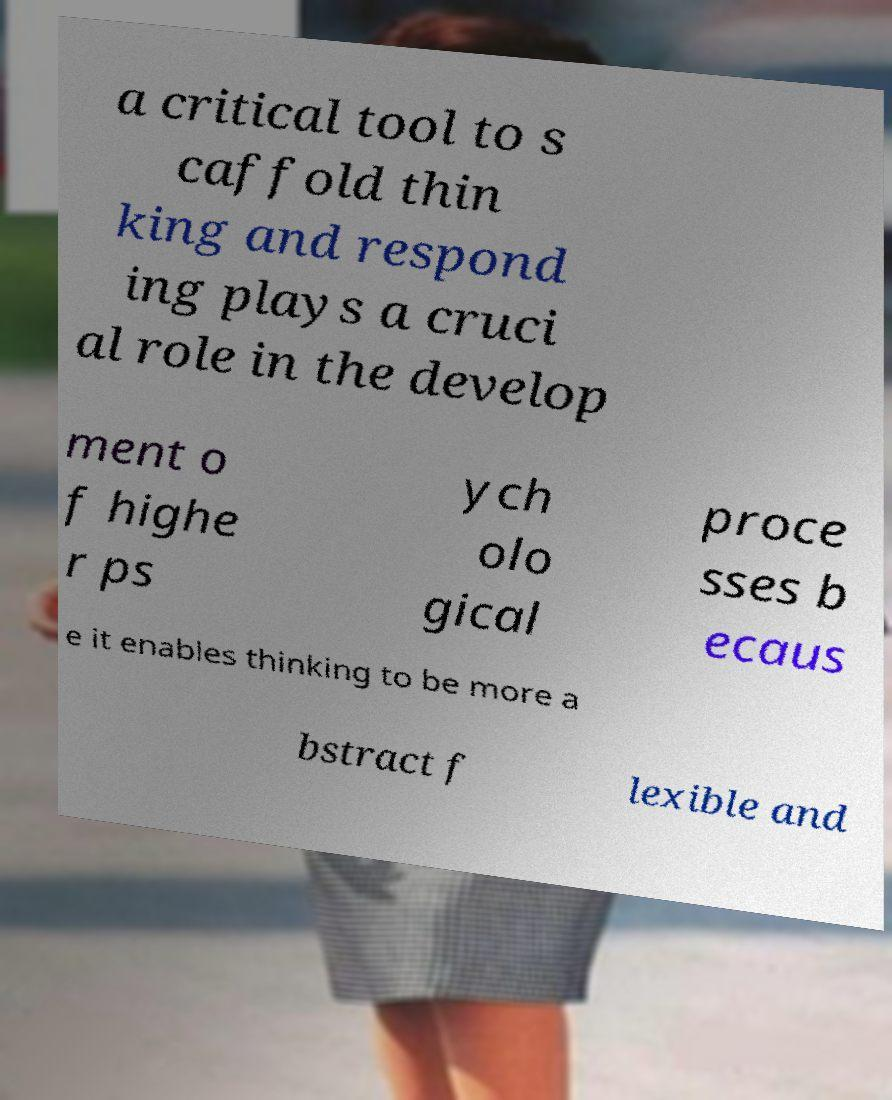Please read and relay the text visible in this image. What does it say? a critical tool to s caffold thin king and respond ing plays a cruci al role in the develop ment o f highe r ps ych olo gical proce sses b ecaus e it enables thinking to be more a bstract f lexible and 